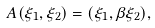Convert formula to latex. <formula><loc_0><loc_0><loc_500><loc_500>A ( \xi _ { 1 } , \xi _ { 2 } ) = ( \xi _ { 1 } , \beta \xi _ { 2 } ) ,</formula> 